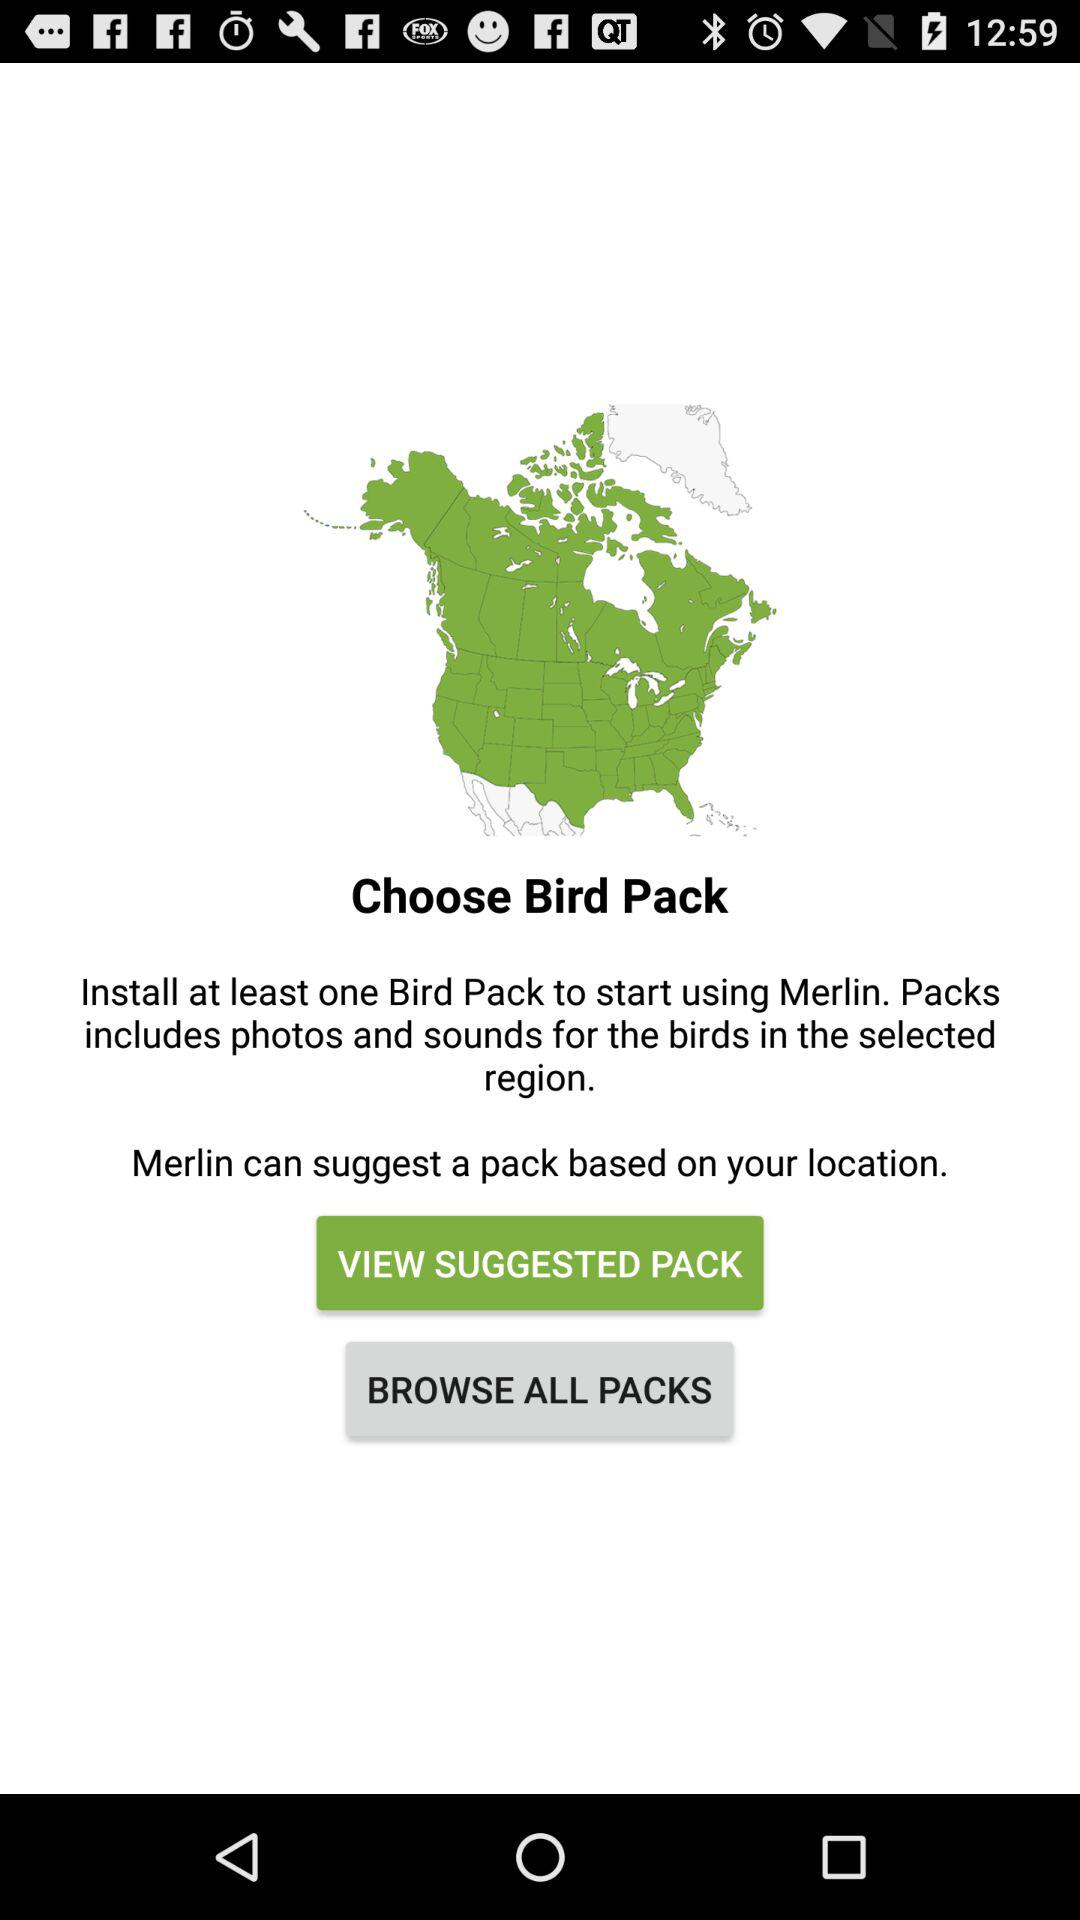How many packs are available?
When the provided information is insufficient, respond with <no answer>. <no answer> 